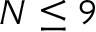Convert formula to latex. <formula><loc_0><loc_0><loc_500><loc_500>N \leq 9</formula> 